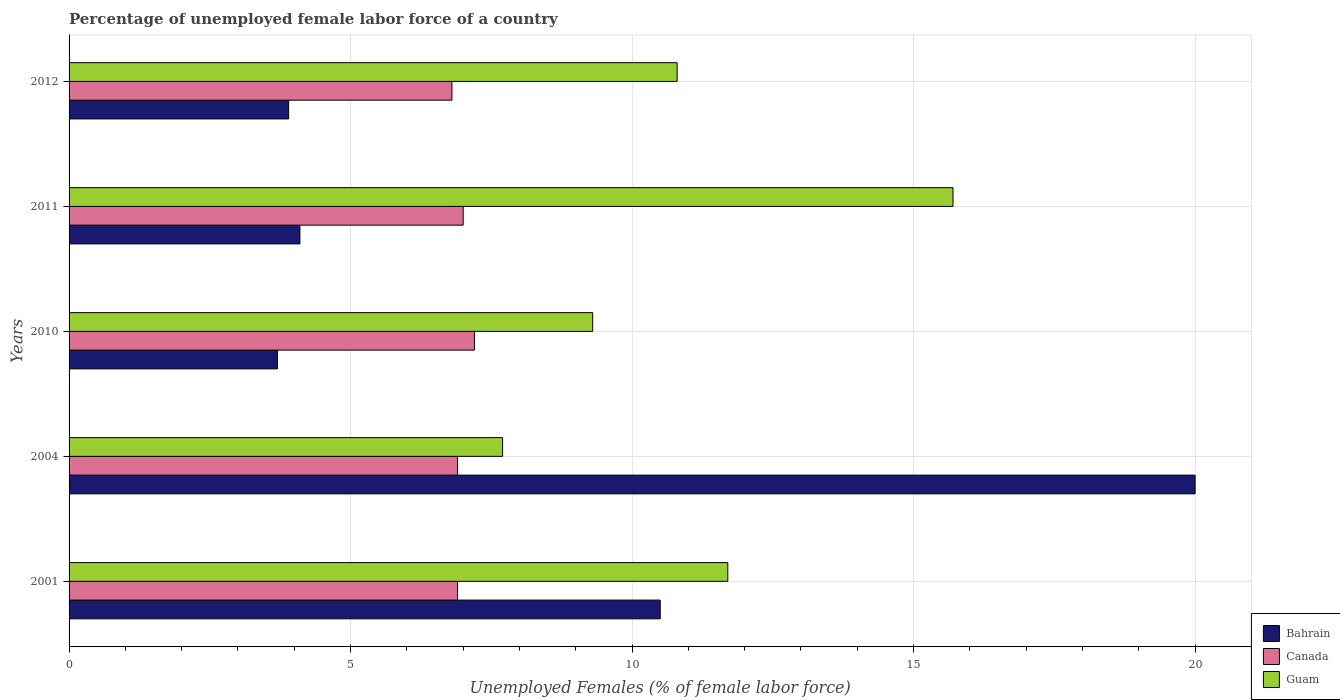How many groups of bars are there?
Ensure brevity in your answer.  5. Are the number of bars on each tick of the Y-axis equal?
Provide a succinct answer. Yes. How many bars are there on the 1st tick from the bottom?
Make the answer very short. 3. In how many cases, is the number of bars for a given year not equal to the number of legend labels?
Offer a terse response. 0. What is the percentage of unemployed female labor force in Guam in 2004?
Give a very brief answer. 7.7. Across all years, what is the maximum percentage of unemployed female labor force in Guam?
Ensure brevity in your answer.  15.7. Across all years, what is the minimum percentage of unemployed female labor force in Guam?
Offer a terse response. 7.7. In which year was the percentage of unemployed female labor force in Guam maximum?
Offer a terse response. 2011. What is the total percentage of unemployed female labor force in Guam in the graph?
Your answer should be compact. 55.2. What is the difference between the percentage of unemployed female labor force in Guam in 2011 and the percentage of unemployed female labor force in Canada in 2001?
Provide a succinct answer. 8.8. What is the average percentage of unemployed female labor force in Canada per year?
Keep it short and to the point. 6.96. In the year 2010, what is the difference between the percentage of unemployed female labor force in Guam and percentage of unemployed female labor force in Canada?
Keep it short and to the point. 2.1. In how many years, is the percentage of unemployed female labor force in Bahrain greater than 20 %?
Offer a very short reply. 0. What is the ratio of the percentage of unemployed female labor force in Canada in 2010 to that in 2011?
Keep it short and to the point. 1.03. Is the percentage of unemployed female labor force in Canada in 2004 less than that in 2011?
Offer a very short reply. Yes. Is the difference between the percentage of unemployed female labor force in Guam in 2011 and 2012 greater than the difference between the percentage of unemployed female labor force in Canada in 2011 and 2012?
Your answer should be compact. Yes. What is the difference between the highest and the second highest percentage of unemployed female labor force in Canada?
Keep it short and to the point. 0.2. What is the difference between the highest and the lowest percentage of unemployed female labor force in Bahrain?
Make the answer very short. 16.3. In how many years, is the percentage of unemployed female labor force in Bahrain greater than the average percentage of unemployed female labor force in Bahrain taken over all years?
Offer a very short reply. 2. What does the 1st bar from the top in 2010 represents?
Make the answer very short. Guam. What does the 2nd bar from the bottom in 2004 represents?
Make the answer very short. Canada. Is it the case that in every year, the sum of the percentage of unemployed female labor force in Canada and percentage of unemployed female labor force in Bahrain is greater than the percentage of unemployed female labor force in Guam?
Make the answer very short. No. How many bars are there?
Offer a terse response. 15. How many years are there in the graph?
Ensure brevity in your answer.  5. What is the difference between two consecutive major ticks on the X-axis?
Provide a succinct answer. 5. Does the graph contain grids?
Give a very brief answer. Yes. Where does the legend appear in the graph?
Your answer should be compact. Bottom right. What is the title of the graph?
Your answer should be compact. Percentage of unemployed female labor force of a country. What is the label or title of the X-axis?
Offer a terse response. Unemployed Females (% of female labor force). What is the Unemployed Females (% of female labor force) of Bahrain in 2001?
Your response must be concise. 10.5. What is the Unemployed Females (% of female labor force) of Canada in 2001?
Provide a short and direct response. 6.9. What is the Unemployed Females (% of female labor force) of Guam in 2001?
Offer a terse response. 11.7. What is the Unemployed Females (% of female labor force) in Bahrain in 2004?
Make the answer very short. 20. What is the Unemployed Females (% of female labor force) of Canada in 2004?
Provide a short and direct response. 6.9. What is the Unemployed Females (% of female labor force) of Guam in 2004?
Ensure brevity in your answer.  7.7. What is the Unemployed Females (% of female labor force) in Bahrain in 2010?
Your answer should be compact. 3.7. What is the Unemployed Females (% of female labor force) in Canada in 2010?
Keep it short and to the point. 7.2. What is the Unemployed Females (% of female labor force) of Guam in 2010?
Provide a short and direct response. 9.3. What is the Unemployed Females (% of female labor force) of Bahrain in 2011?
Keep it short and to the point. 4.1. What is the Unemployed Females (% of female labor force) in Canada in 2011?
Your response must be concise. 7. What is the Unemployed Females (% of female labor force) in Guam in 2011?
Your answer should be compact. 15.7. What is the Unemployed Females (% of female labor force) in Bahrain in 2012?
Keep it short and to the point. 3.9. What is the Unemployed Females (% of female labor force) in Canada in 2012?
Your response must be concise. 6.8. What is the Unemployed Females (% of female labor force) of Guam in 2012?
Offer a very short reply. 10.8. Across all years, what is the maximum Unemployed Females (% of female labor force) in Bahrain?
Your response must be concise. 20. Across all years, what is the maximum Unemployed Females (% of female labor force) in Canada?
Provide a succinct answer. 7.2. Across all years, what is the maximum Unemployed Females (% of female labor force) of Guam?
Provide a succinct answer. 15.7. Across all years, what is the minimum Unemployed Females (% of female labor force) of Bahrain?
Your response must be concise. 3.7. Across all years, what is the minimum Unemployed Females (% of female labor force) of Canada?
Provide a short and direct response. 6.8. Across all years, what is the minimum Unemployed Females (% of female labor force) of Guam?
Offer a very short reply. 7.7. What is the total Unemployed Females (% of female labor force) of Bahrain in the graph?
Offer a very short reply. 42.2. What is the total Unemployed Females (% of female labor force) of Canada in the graph?
Your response must be concise. 34.8. What is the total Unemployed Females (% of female labor force) of Guam in the graph?
Your answer should be very brief. 55.2. What is the difference between the Unemployed Females (% of female labor force) in Bahrain in 2001 and that in 2004?
Provide a succinct answer. -9.5. What is the difference between the Unemployed Females (% of female labor force) of Canada in 2001 and that in 2004?
Your response must be concise. 0. What is the difference between the Unemployed Females (% of female labor force) of Bahrain in 2001 and that in 2010?
Keep it short and to the point. 6.8. What is the difference between the Unemployed Females (% of female labor force) of Canada in 2001 and that in 2010?
Provide a succinct answer. -0.3. What is the difference between the Unemployed Females (% of female labor force) in Guam in 2001 and that in 2012?
Your response must be concise. 0.9. What is the difference between the Unemployed Females (% of female labor force) in Bahrain in 2004 and that in 2010?
Provide a short and direct response. 16.3. What is the difference between the Unemployed Females (% of female labor force) in Canada in 2004 and that in 2010?
Give a very brief answer. -0.3. What is the difference between the Unemployed Females (% of female labor force) in Canada in 2004 and that in 2011?
Provide a short and direct response. -0.1. What is the difference between the Unemployed Females (% of female labor force) in Guam in 2004 and that in 2011?
Your answer should be very brief. -8. What is the difference between the Unemployed Females (% of female labor force) of Bahrain in 2004 and that in 2012?
Your response must be concise. 16.1. What is the difference between the Unemployed Females (% of female labor force) in Guam in 2004 and that in 2012?
Ensure brevity in your answer.  -3.1. What is the difference between the Unemployed Females (% of female labor force) in Bahrain in 2010 and that in 2011?
Ensure brevity in your answer.  -0.4. What is the difference between the Unemployed Females (% of female labor force) of Bahrain in 2010 and that in 2012?
Make the answer very short. -0.2. What is the difference between the Unemployed Females (% of female labor force) of Canada in 2010 and that in 2012?
Provide a short and direct response. 0.4. What is the difference between the Unemployed Females (% of female labor force) in Bahrain in 2011 and that in 2012?
Provide a succinct answer. 0.2. What is the difference between the Unemployed Females (% of female labor force) in Guam in 2011 and that in 2012?
Offer a very short reply. 4.9. What is the difference between the Unemployed Females (% of female labor force) of Bahrain in 2001 and the Unemployed Females (% of female labor force) of Canada in 2004?
Offer a very short reply. 3.6. What is the difference between the Unemployed Females (% of female labor force) of Canada in 2001 and the Unemployed Females (% of female labor force) of Guam in 2004?
Give a very brief answer. -0.8. What is the difference between the Unemployed Females (% of female labor force) of Bahrain in 2001 and the Unemployed Females (% of female labor force) of Guam in 2010?
Make the answer very short. 1.2. What is the difference between the Unemployed Females (% of female labor force) in Bahrain in 2001 and the Unemployed Females (% of female labor force) in Guam in 2011?
Provide a succinct answer. -5.2. What is the difference between the Unemployed Females (% of female labor force) of Bahrain in 2001 and the Unemployed Females (% of female labor force) of Canada in 2012?
Keep it short and to the point. 3.7. What is the difference between the Unemployed Females (% of female labor force) of Canada in 2001 and the Unemployed Females (% of female labor force) of Guam in 2012?
Make the answer very short. -3.9. What is the difference between the Unemployed Females (% of female labor force) of Bahrain in 2004 and the Unemployed Females (% of female labor force) of Guam in 2012?
Offer a very short reply. 9.2. What is the difference between the Unemployed Females (% of female labor force) in Bahrain in 2010 and the Unemployed Females (% of female labor force) in Guam in 2011?
Offer a very short reply. -12. What is the difference between the Unemployed Females (% of female labor force) in Canada in 2010 and the Unemployed Females (% of female labor force) in Guam in 2012?
Your answer should be very brief. -3.6. What is the difference between the Unemployed Females (% of female labor force) of Canada in 2011 and the Unemployed Females (% of female labor force) of Guam in 2012?
Provide a short and direct response. -3.8. What is the average Unemployed Females (% of female labor force) of Bahrain per year?
Your answer should be very brief. 8.44. What is the average Unemployed Females (% of female labor force) of Canada per year?
Ensure brevity in your answer.  6.96. What is the average Unemployed Females (% of female labor force) in Guam per year?
Offer a terse response. 11.04. In the year 2004, what is the difference between the Unemployed Females (% of female labor force) in Bahrain and Unemployed Females (% of female labor force) in Canada?
Your response must be concise. 13.1. In the year 2004, what is the difference between the Unemployed Females (% of female labor force) of Bahrain and Unemployed Females (% of female labor force) of Guam?
Your answer should be very brief. 12.3. In the year 2004, what is the difference between the Unemployed Females (% of female labor force) in Canada and Unemployed Females (% of female labor force) in Guam?
Make the answer very short. -0.8. In the year 2010, what is the difference between the Unemployed Females (% of female labor force) in Bahrain and Unemployed Females (% of female labor force) in Guam?
Your answer should be very brief. -5.6. In the year 2011, what is the difference between the Unemployed Females (% of female labor force) of Canada and Unemployed Females (% of female labor force) of Guam?
Make the answer very short. -8.7. In the year 2012, what is the difference between the Unemployed Females (% of female labor force) of Bahrain and Unemployed Females (% of female labor force) of Canada?
Your response must be concise. -2.9. In the year 2012, what is the difference between the Unemployed Females (% of female labor force) in Bahrain and Unemployed Females (% of female labor force) in Guam?
Provide a short and direct response. -6.9. What is the ratio of the Unemployed Females (% of female labor force) of Bahrain in 2001 to that in 2004?
Offer a terse response. 0.53. What is the ratio of the Unemployed Females (% of female labor force) of Canada in 2001 to that in 2004?
Give a very brief answer. 1. What is the ratio of the Unemployed Females (% of female labor force) in Guam in 2001 to that in 2004?
Your answer should be compact. 1.52. What is the ratio of the Unemployed Females (% of female labor force) in Bahrain in 2001 to that in 2010?
Keep it short and to the point. 2.84. What is the ratio of the Unemployed Females (% of female labor force) of Guam in 2001 to that in 2010?
Give a very brief answer. 1.26. What is the ratio of the Unemployed Females (% of female labor force) in Bahrain in 2001 to that in 2011?
Provide a short and direct response. 2.56. What is the ratio of the Unemployed Females (% of female labor force) of Canada in 2001 to that in 2011?
Offer a very short reply. 0.99. What is the ratio of the Unemployed Females (% of female labor force) in Guam in 2001 to that in 2011?
Your response must be concise. 0.75. What is the ratio of the Unemployed Females (% of female labor force) of Bahrain in 2001 to that in 2012?
Keep it short and to the point. 2.69. What is the ratio of the Unemployed Females (% of female labor force) of Canada in 2001 to that in 2012?
Give a very brief answer. 1.01. What is the ratio of the Unemployed Females (% of female labor force) of Guam in 2001 to that in 2012?
Provide a short and direct response. 1.08. What is the ratio of the Unemployed Females (% of female labor force) in Bahrain in 2004 to that in 2010?
Provide a short and direct response. 5.41. What is the ratio of the Unemployed Females (% of female labor force) of Canada in 2004 to that in 2010?
Keep it short and to the point. 0.96. What is the ratio of the Unemployed Females (% of female labor force) in Guam in 2004 to that in 2010?
Give a very brief answer. 0.83. What is the ratio of the Unemployed Females (% of female labor force) of Bahrain in 2004 to that in 2011?
Provide a succinct answer. 4.88. What is the ratio of the Unemployed Females (% of female labor force) in Canada in 2004 to that in 2011?
Keep it short and to the point. 0.99. What is the ratio of the Unemployed Females (% of female labor force) in Guam in 2004 to that in 2011?
Offer a very short reply. 0.49. What is the ratio of the Unemployed Females (% of female labor force) of Bahrain in 2004 to that in 2012?
Offer a terse response. 5.13. What is the ratio of the Unemployed Females (% of female labor force) in Canada in 2004 to that in 2012?
Your response must be concise. 1.01. What is the ratio of the Unemployed Females (% of female labor force) of Guam in 2004 to that in 2012?
Make the answer very short. 0.71. What is the ratio of the Unemployed Females (% of female labor force) in Bahrain in 2010 to that in 2011?
Provide a short and direct response. 0.9. What is the ratio of the Unemployed Females (% of female labor force) of Canada in 2010 to that in 2011?
Offer a very short reply. 1.03. What is the ratio of the Unemployed Females (% of female labor force) in Guam in 2010 to that in 2011?
Keep it short and to the point. 0.59. What is the ratio of the Unemployed Females (% of female labor force) of Bahrain in 2010 to that in 2012?
Your answer should be very brief. 0.95. What is the ratio of the Unemployed Females (% of female labor force) in Canada in 2010 to that in 2012?
Provide a short and direct response. 1.06. What is the ratio of the Unemployed Females (% of female labor force) in Guam in 2010 to that in 2012?
Your answer should be very brief. 0.86. What is the ratio of the Unemployed Females (% of female labor force) in Bahrain in 2011 to that in 2012?
Provide a short and direct response. 1.05. What is the ratio of the Unemployed Females (% of female labor force) in Canada in 2011 to that in 2012?
Provide a short and direct response. 1.03. What is the ratio of the Unemployed Females (% of female labor force) of Guam in 2011 to that in 2012?
Offer a terse response. 1.45. What is the difference between the highest and the second highest Unemployed Females (% of female labor force) in Bahrain?
Keep it short and to the point. 9.5. What is the difference between the highest and the second highest Unemployed Females (% of female labor force) of Canada?
Offer a terse response. 0.2. What is the difference between the highest and the second highest Unemployed Females (% of female labor force) in Guam?
Provide a succinct answer. 4. What is the difference between the highest and the lowest Unemployed Females (% of female labor force) of Bahrain?
Make the answer very short. 16.3. What is the difference between the highest and the lowest Unemployed Females (% of female labor force) of Canada?
Provide a succinct answer. 0.4. 